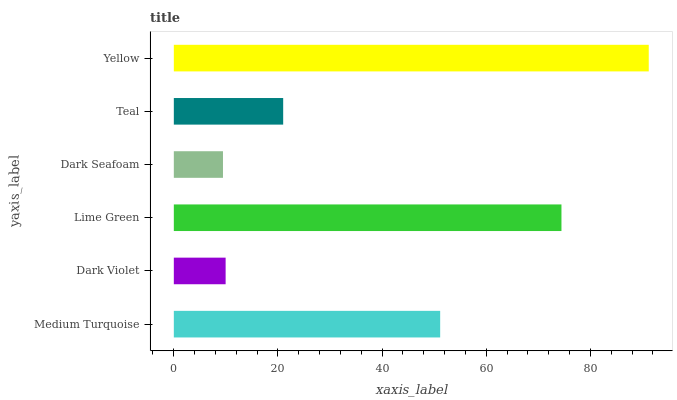Is Dark Seafoam the minimum?
Answer yes or no. Yes. Is Yellow the maximum?
Answer yes or no. Yes. Is Dark Violet the minimum?
Answer yes or no. No. Is Dark Violet the maximum?
Answer yes or no. No. Is Medium Turquoise greater than Dark Violet?
Answer yes or no. Yes. Is Dark Violet less than Medium Turquoise?
Answer yes or no. Yes. Is Dark Violet greater than Medium Turquoise?
Answer yes or no. No. Is Medium Turquoise less than Dark Violet?
Answer yes or no. No. Is Medium Turquoise the high median?
Answer yes or no. Yes. Is Teal the low median?
Answer yes or no. Yes. Is Dark Violet the high median?
Answer yes or no. No. Is Lime Green the low median?
Answer yes or no. No. 